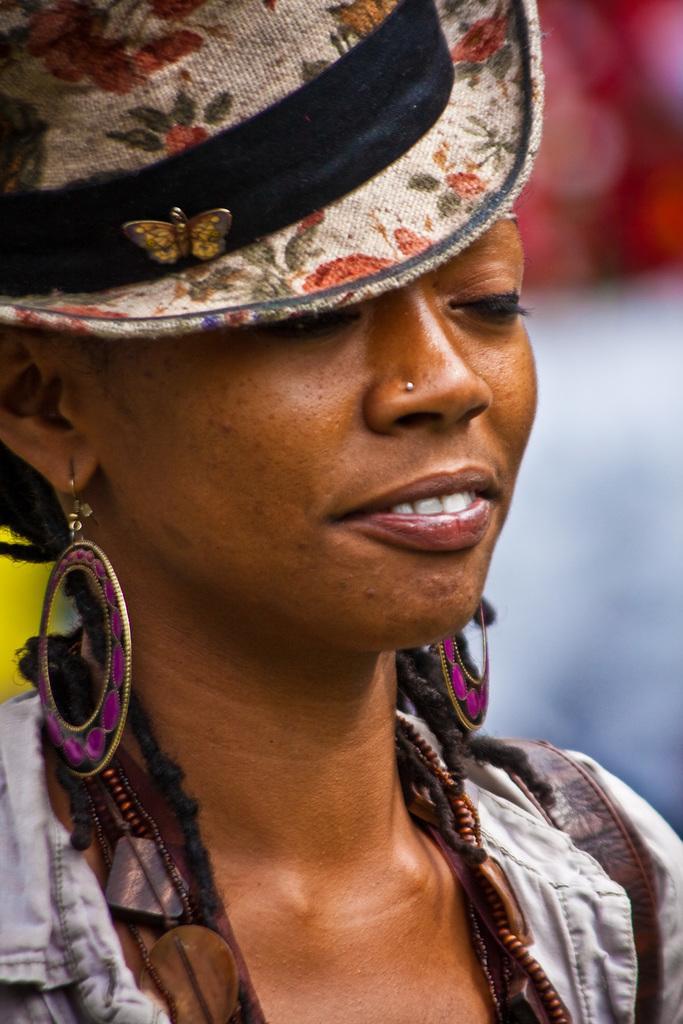Can you describe this image briefly? Here we can see a woman and she wore a cap. There is a blur background. 